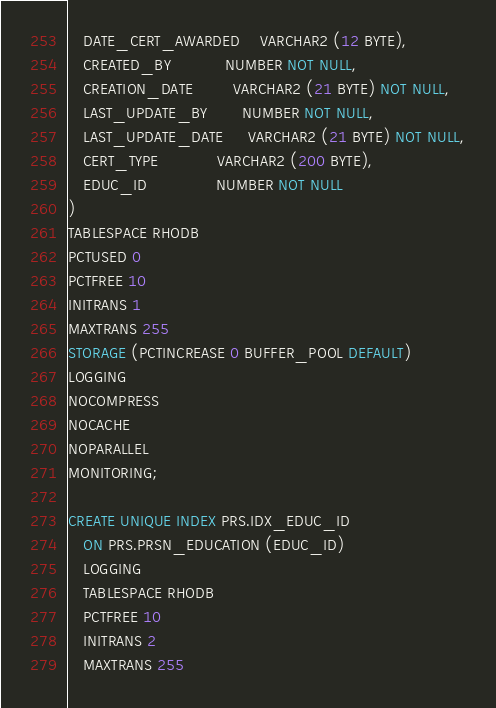Convert code to text. <code><loc_0><loc_0><loc_500><loc_500><_SQL_>   DATE_CERT_AWARDED    VARCHAR2 (12 BYTE),
   CREATED_BY           NUMBER NOT NULL,
   CREATION_DATE        VARCHAR2 (21 BYTE) NOT NULL,
   LAST_UPDATE_BY       NUMBER NOT NULL,
   LAST_UPDATE_DATE     VARCHAR2 (21 BYTE) NOT NULL,
   CERT_TYPE            VARCHAR2 (200 BYTE),
   EDUC_ID              NUMBER NOT NULL
)
TABLESPACE RHODB
PCTUSED 0
PCTFREE 10
INITRANS 1
MAXTRANS 255
STORAGE (PCTINCREASE 0 BUFFER_POOL DEFAULT)
LOGGING
NOCOMPRESS
NOCACHE
NOPARALLEL
MONITORING;

CREATE UNIQUE INDEX PRS.IDX_EDUC_ID
   ON PRS.PRSN_EDUCATION (EDUC_ID)
   LOGGING
   TABLESPACE RHODB
   PCTFREE 10
   INITRANS 2
   MAXTRANS 255</code> 